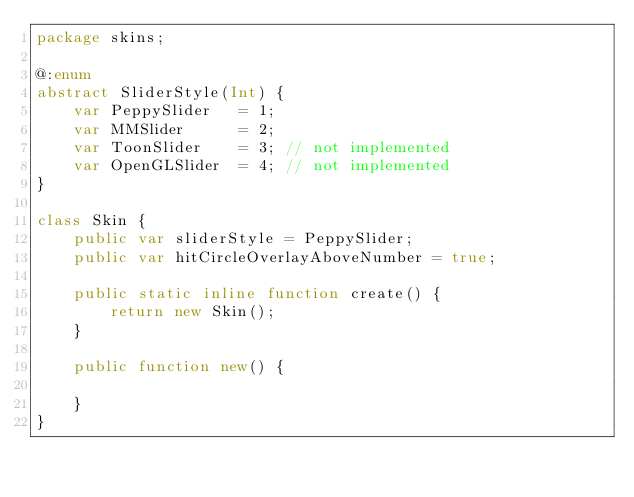Convert code to text. <code><loc_0><loc_0><loc_500><loc_500><_Haxe_>package skins;

@:enum
abstract SliderStyle(Int) {
    var PeppySlider   = 1;
    var MMSlider      = 2;
    var ToonSlider    = 3; // not implemented
    var OpenGLSlider  = 4; // not implemented
}

class Skin {
    public var sliderStyle = PeppySlider;
    public var hitCircleOverlayAboveNumber = true;

    public static inline function create() {
        return new Skin();
    }

    public function new() {

    }
}</code> 